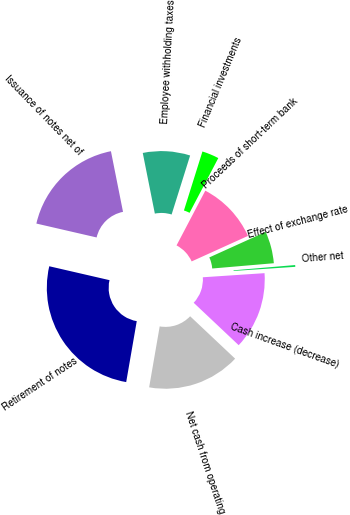<chart> <loc_0><loc_0><loc_500><loc_500><pie_chart><fcel>Net cash from operating<fcel>Retirement of notes<fcel>Issuance of notes net of<fcel>Employee withholding taxes<fcel>Financial investments<fcel>Proceeds of short-term bank<fcel>Effect of exchange rate<fcel>Other net<fcel>Cash increase (decrease)<nl><fcel>15.7%<fcel>25.88%<fcel>18.26%<fcel>7.97%<fcel>2.86%<fcel>10.53%<fcel>5.41%<fcel>0.3%<fcel>13.09%<nl></chart> 